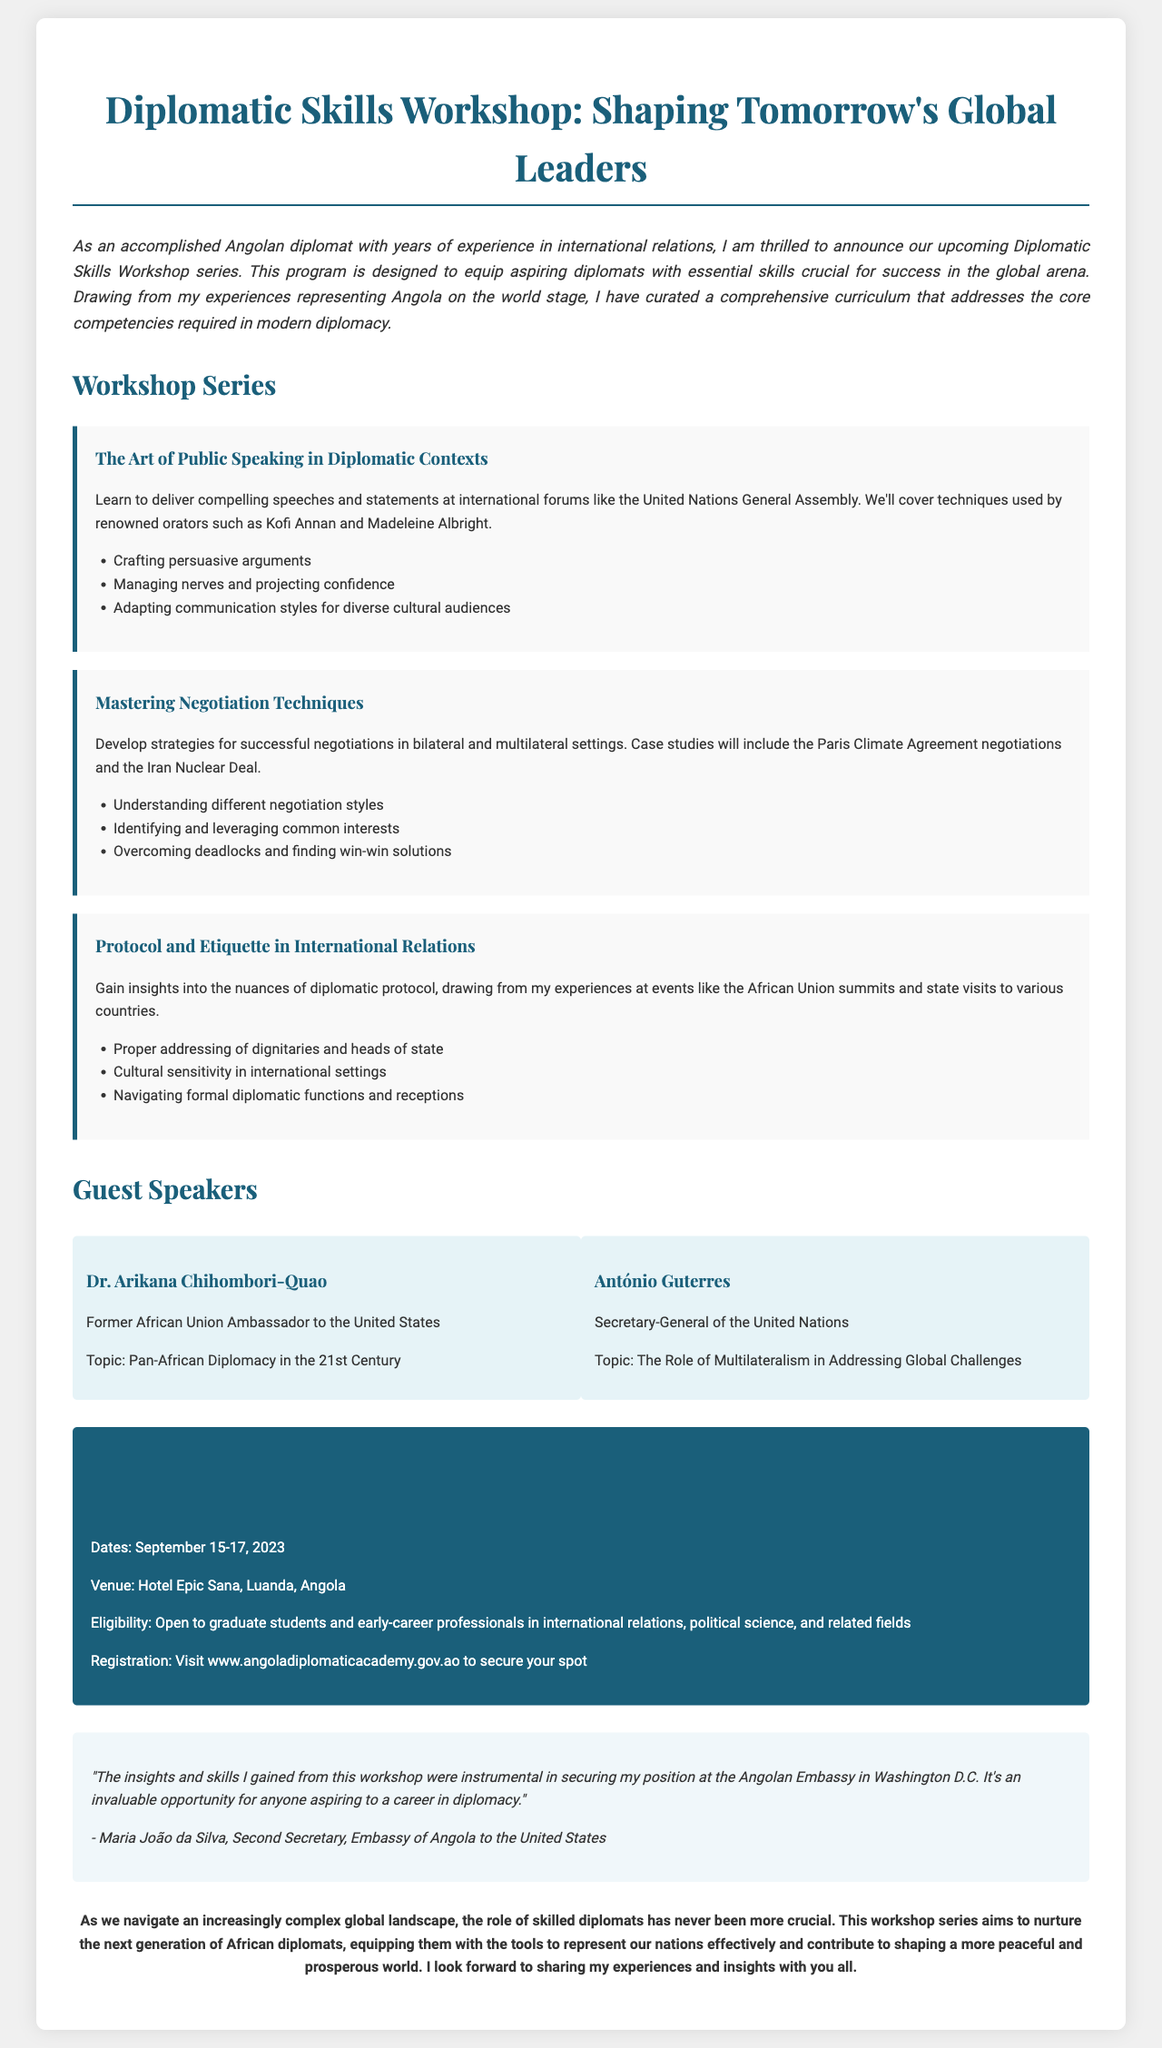What is the title of the workshop series? The title of the workshop series is mentioned at the beginning of the document.
Answer: Diplomatic Skills Workshop: Shaping Tomorrow's Global Leaders Who is the guest speaker from the United Nations? The document lists a guest speaker who holds a position in the United Nations.
Answer: António Guterres What are the dates of the workshop? The practical information section provides the specific dates for the event.
Answer: September 15-17, 2023 What is one of the key topics covered in the "Mastering Negotiation Techniques" workshop? The document lists key topics for each workshop; we look for one from the negotiation workshop.
Answer: Understanding different negotiation styles Who authored the testimonial in the document? The testimonial section includes the name of the author giving praise to the workshop.
Answer: Maria João da Silva What is the venue for the workshop? The practical information section also mentions the location where the workshop will be held.
Answer: Hotel Epic Sana, Luanda, Angola What is the eligibility for attending the workshop? The document specifically states who can attend the workshop under practical information.
Answer: Open to graduate students and early-career professionals What is the main purpose of the workshop series? The introduction paragraph outlines the intention behind organizing the workshop series.
Answer: Equip aspiring diplomats with essential skills 